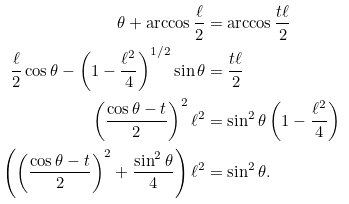Convert formula to latex. <formula><loc_0><loc_0><loc_500><loc_500>\theta + \arccos \frac { \ell } { 2 } & = \arccos \frac { t \ell } { 2 } \\ \frac { \ell } { 2 } \cos \theta - \left ( 1 - \frac { \ell ^ { 2 } } { 4 } \right ) ^ { 1 / 2 } \sin \theta & = \frac { t \ell } { 2 } \\ \left ( \frac { \cos \theta - t } { 2 } \right ) ^ { 2 } \ell ^ { 2 } & = \sin ^ { 2 } \theta \left ( 1 - \frac { \ell ^ { 2 } } { 4 } \right ) \\ \left ( \left ( \frac { \cos \theta - t } { 2 } \right ) ^ { 2 } + \frac { \sin ^ { 2 } \theta } { 4 } \right ) \ell ^ { 2 } & = \sin ^ { 2 } \theta .</formula> 